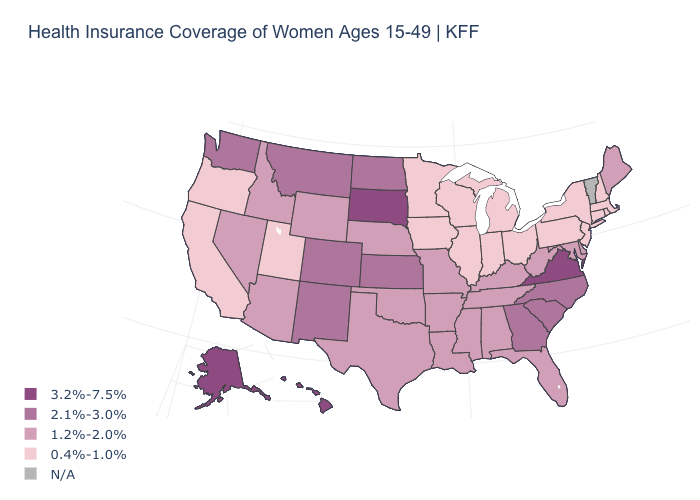What is the highest value in states that border New Jersey?
Write a very short answer. 1.2%-2.0%. Is the legend a continuous bar?
Keep it brief. No. Is the legend a continuous bar?
Keep it brief. No. Does Maine have the highest value in the Northeast?
Keep it brief. Yes. Which states have the lowest value in the USA?
Quick response, please. California, Connecticut, Illinois, Indiana, Iowa, Massachusetts, Michigan, Minnesota, New Hampshire, New Jersey, New York, Ohio, Oregon, Pennsylvania, Rhode Island, Utah, Wisconsin. What is the value of Wisconsin?
Give a very brief answer. 0.4%-1.0%. Among the states that border Texas , which have the highest value?
Quick response, please. New Mexico. Which states have the highest value in the USA?
Keep it brief. Alaska, Hawaii, South Dakota, Virginia. What is the highest value in the USA?
Answer briefly. 3.2%-7.5%. What is the lowest value in the USA?
Be succinct. 0.4%-1.0%. What is the value of Louisiana?
Write a very short answer. 1.2%-2.0%. Does the first symbol in the legend represent the smallest category?
Keep it brief. No. What is the value of Indiana?
Short answer required. 0.4%-1.0%. What is the highest value in states that border Virginia?
Write a very short answer. 2.1%-3.0%. What is the highest value in states that border Indiana?
Give a very brief answer. 1.2%-2.0%. 